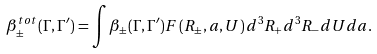<formula> <loc_0><loc_0><loc_500><loc_500>\beta _ { \pm } ^ { t o t } ( \Gamma , \Gamma ^ { \prime } ) = \int \beta _ { \pm } ( \Gamma , \Gamma ^ { \prime } ) F \left ( R _ { \pm } , a , U \right ) d ^ { 3 } R _ { + } d ^ { 3 } R _ { - } d U d a .</formula> 